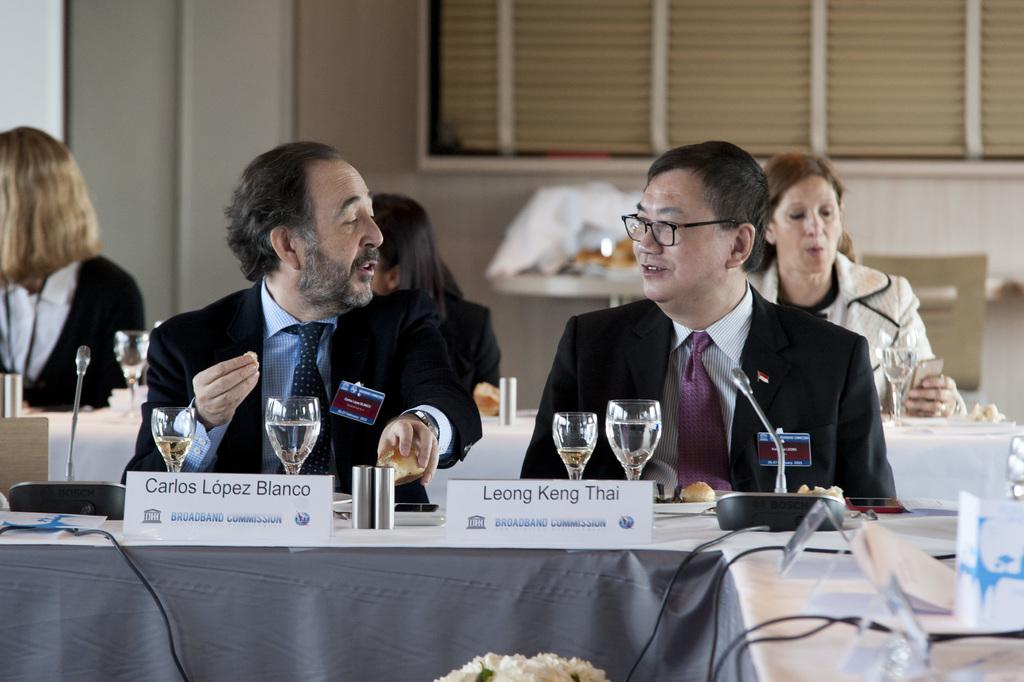<image>
Summarize the visual content of the image. Carlos Lopez Blanco sits at a table beside Leong Keng Thai. 